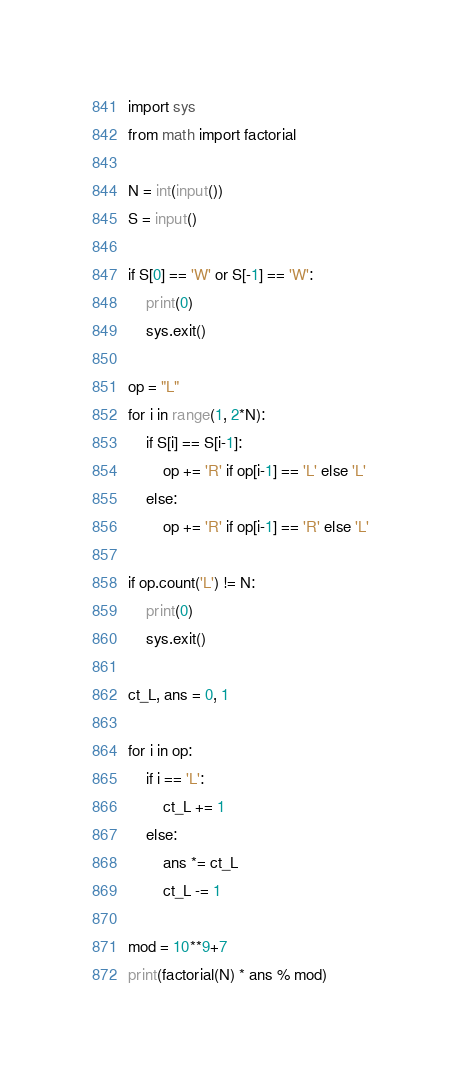Convert code to text. <code><loc_0><loc_0><loc_500><loc_500><_Python_>import sys
from math import factorial

N = int(input())
S = input()

if S[0] == 'W' or S[-1] == 'W':
    print(0)
    sys.exit()

op = "L"
for i in range(1, 2*N):
    if S[i] == S[i-1]:
        op += 'R' if op[i-1] == 'L' else 'L'
    else:
        op += 'R' if op[i-1] == 'R' else 'L'

if op.count('L') != N:
    print(0)
    sys.exit()

ct_L, ans = 0, 1

for i in op:
    if i == 'L':
        ct_L += 1
    else:
        ans *= ct_L
        ct_L -= 1

mod = 10**9+7
print(factorial(N) * ans % mod)
</code> 